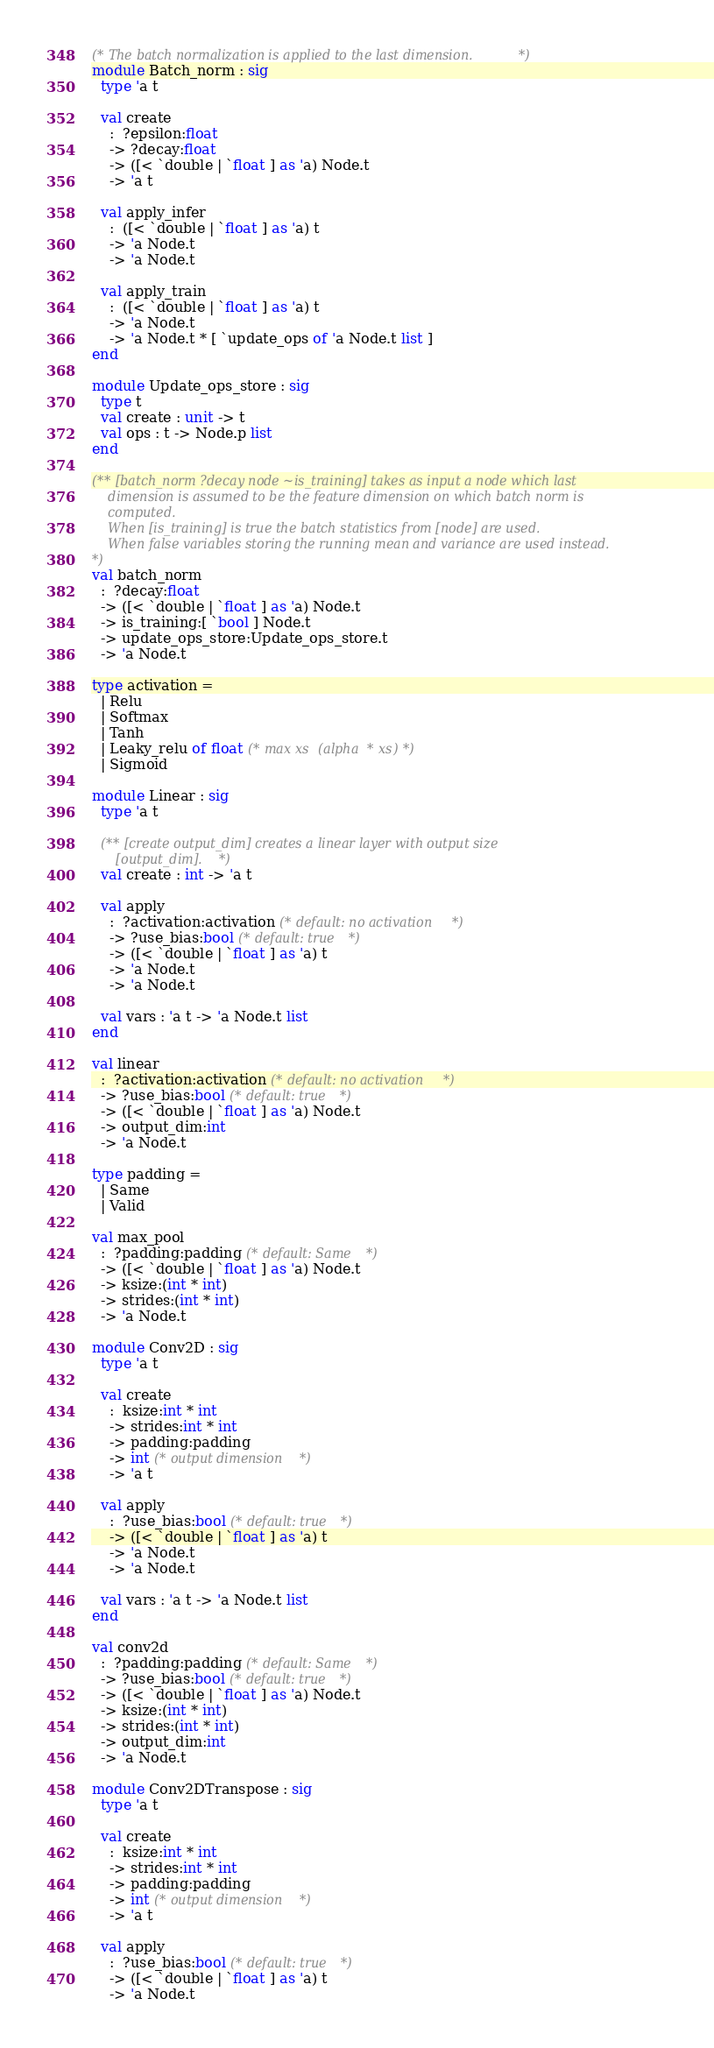<code> <loc_0><loc_0><loc_500><loc_500><_OCaml_>(* The batch normalization is applied to the last dimension. *)
module Batch_norm : sig
  type 'a t

  val create
    :  ?epsilon:float
    -> ?decay:float
    -> ([< `double | `float ] as 'a) Node.t
    -> 'a t

  val apply_infer
    :  ([< `double | `float ] as 'a) t
    -> 'a Node.t
    -> 'a Node.t

  val apply_train
    :  ([< `double | `float ] as 'a) t
    -> 'a Node.t
    -> 'a Node.t * [ `update_ops of 'a Node.t list ]
end

module Update_ops_store : sig
  type t
  val create : unit -> t
  val ops : t -> Node.p list
end

(** [batch_norm ?decay node ~is_training] takes as input a node which last
    dimension is assumed to be the feature dimension on which batch norm is
    computed.
    When [is_training] is true the batch statistics from [node] are used.
    When false variables storing the running mean and variance are used instead.
*)
val batch_norm
  :  ?decay:float
  -> ([< `double | `float ] as 'a) Node.t
  -> is_training:[ `bool ] Node.t
  -> update_ops_store:Update_ops_store.t
  -> 'a Node.t

type activation =
  | Relu
  | Softmax
  | Tanh
  | Leaky_relu of float (* max xs (alpha * xs) *)
  | Sigmoid

module Linear : sig
  type 'a t

  (** [create output_dim] creates a linear layer with output size
      [output_dim]. *)
  val create : int -> 'a t

  val apply
    :  ?activation:activation (* default: no activation *)
    -> ?use_bias:bool (* default: true *)
    -> ([< `double | `float ] as 'a) t
    -> 'a Node.t
    -> 'a Node.t

  val vars : 'a t -> 'a Node.t list
end

val linear
  :  ?activation:activation (* default: no activation *)
  -> ?use_bias:bool (* default: true *)
  -> ([< `double | `float ] as 'a) Node.t
  -> output_dim:int
  -> 'a Node.t

type padding =
  | Same
  | Valid

val max_pool
  :  ?padding:padding (* default: Same *)
  -> ([< `double | `float ] as 'a) Node.t
  -> ksize:(int * int)
  -> strides:(int * int)
  -> 'a Node.t

module Conv2D : sig
  type 'a t

  val create
    :  ksize:int * int
    -> strides:int * int
    -> padding:padding
    -> int (* output dimension *)
    -> 'a t

  val apply
    :  ?use_bias:bool (* default: true *)
    -> ([< `double | `float ] as 'a) t
    -> 'a Node.t
    -> 'a Node.t

  val vars : 'a t -> 'a Node.t list
end

val conv2d
  :  ?padding:padding (* default: Same *)
  -> ?use_bias:bool (* default: true *)
  -> ([< `double | `float ] as 'a) Node.t
  -> ksize:(int * int)
  -> strides:(int * int)
  -> output_dim:int
  -> 'a Node.t

module Conv2DTranspose : sig
  type 'a t

  val create
    :  ksize:int * int
    -> strides:int * int
    -> padding:padding
    -> int (* output dimension *)
    -> 'a t

  val apply
    :  ?use_bias:bool (* default: true *)
    -> ([< `double | `float ] as 'a) t
    -> 'a Node.t</code> 